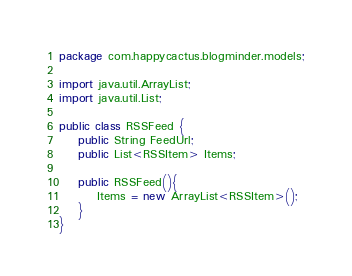Convert code to text. <code><loc_0><loc_0><loc_500><loc_500><_Java_>package com.happycactus.blogminder.models;

import java.util.ArrayList;
import java.util.List;

public class RSSFeed {
    public String FeedUrl;
    public List<RSSItem> Items;

    public RSSFeed(){
        Items = new ArrayList<RSSItem>();
    }
}
</code> 